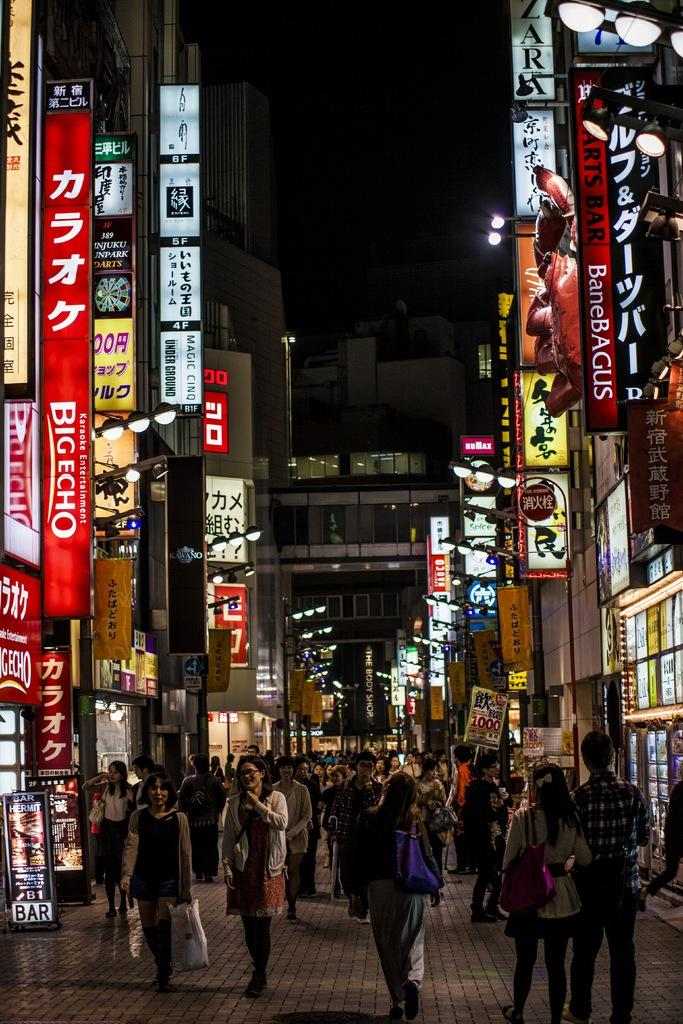<image>
Provide a brief description of the given image. A colourful and busy street scene is surrounded by advertising signs including big echo, arts bar ad others in chinese. 